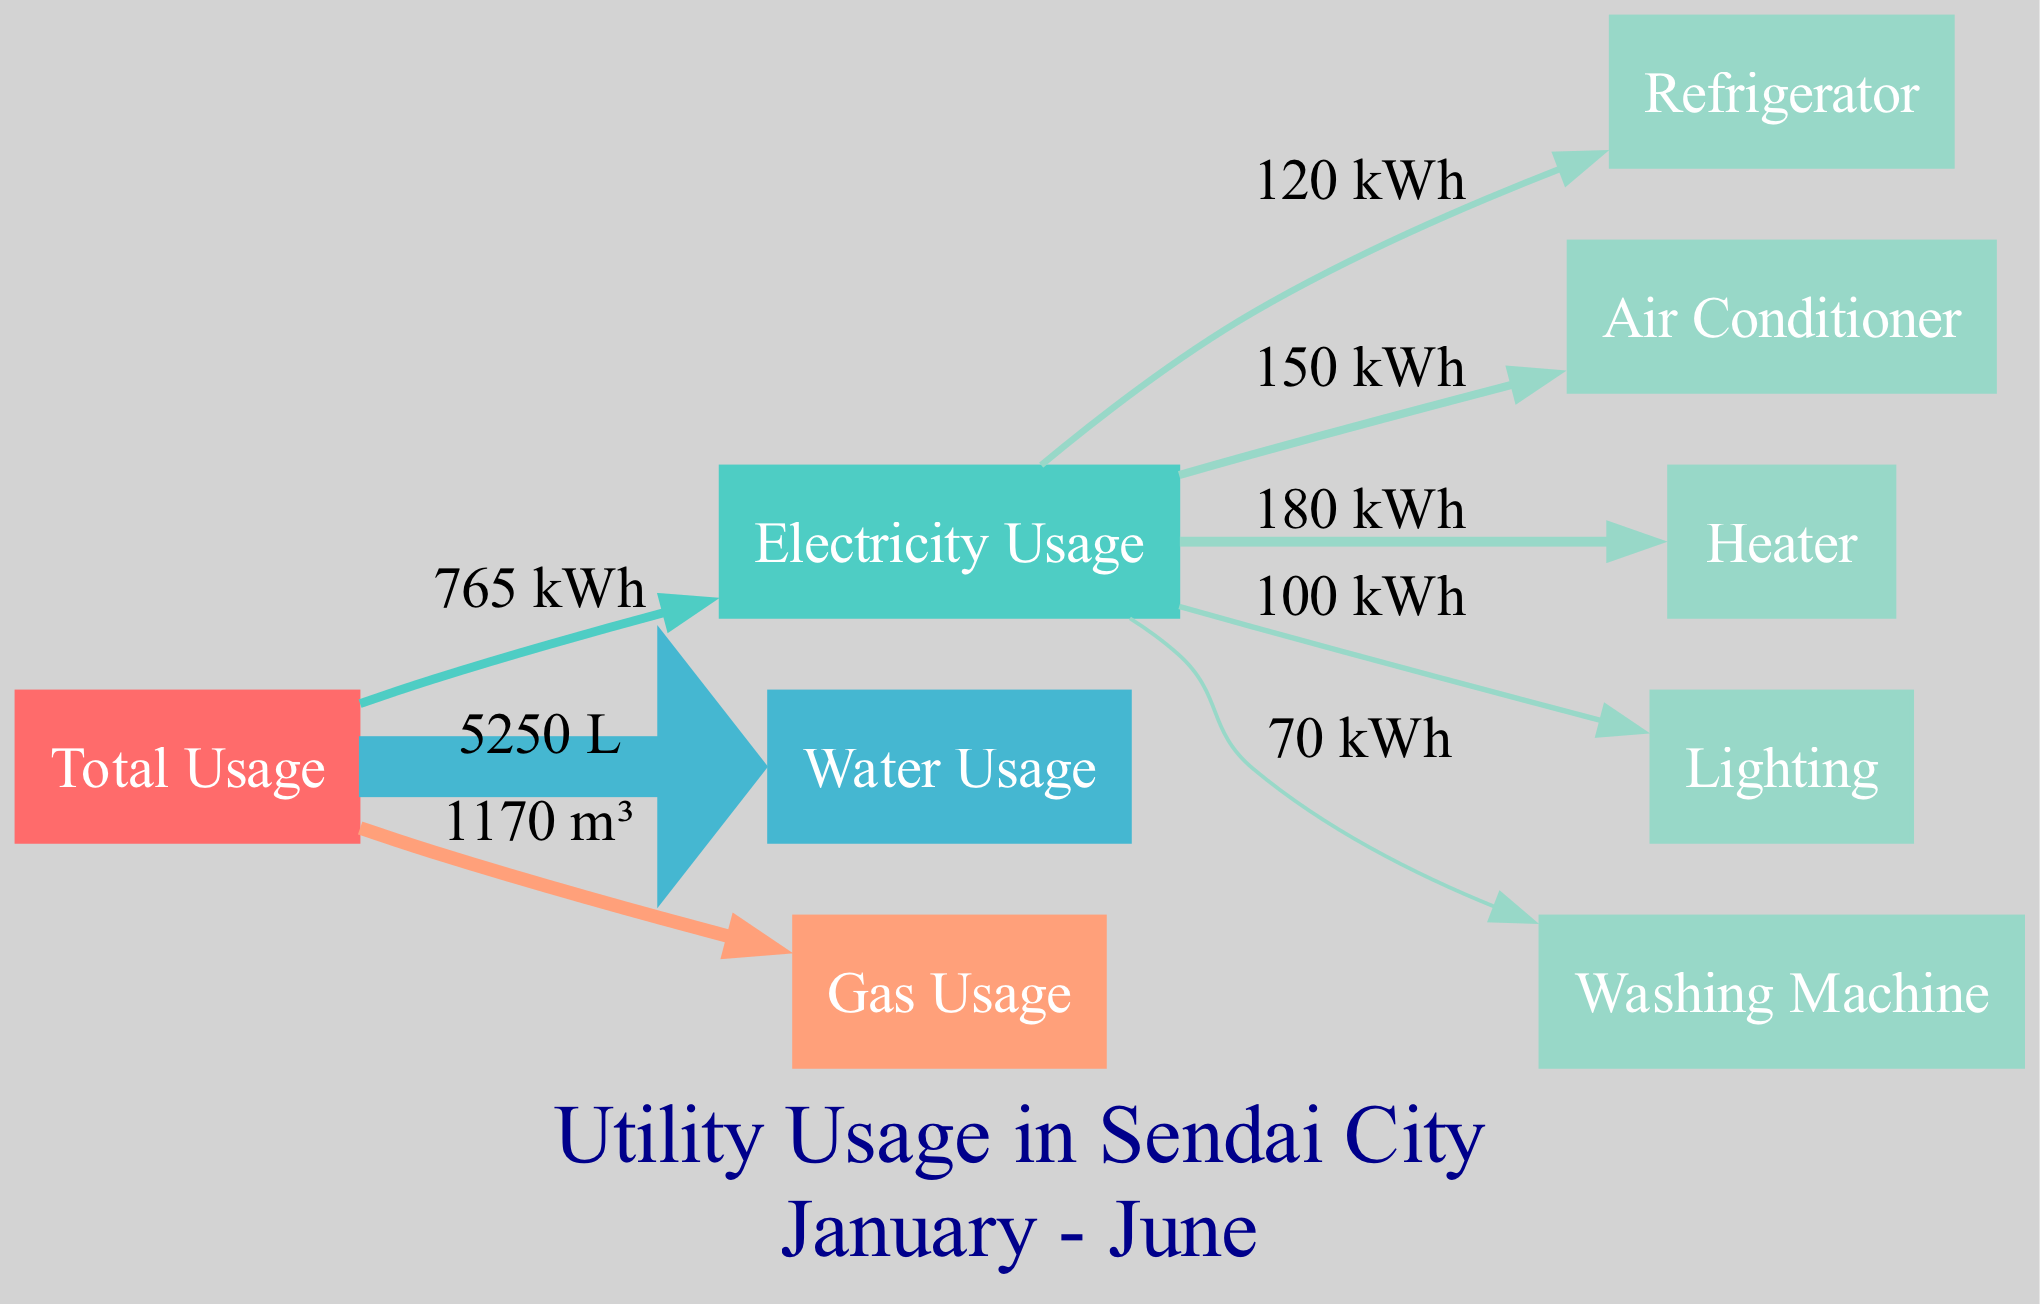What is the total electricity usage over six months? To find the total electricity usage, sum the monthly electricity usage values: 120 + 115 + 130 + 125 + 140 + 135 = 765.
Answer: 765 kWh What is the water usage in April? The diagram indicates that the water usage for April is shown as a specific value, which is listed in the water usage section: 950.
Answer: 950 L Which utility has the highest total usage? To determine which utility has the highest total usage, calculate the total for electricity (765), water (5,350), and gas (1,180). Water has the highest total usage.
Answer: Water How much gas was used in March? The gas usage for March is specifically labeled in the diagram, showing a direct value of 210.
Answer: 210 m³ Which energy appliance uses the least electricity? Evaluate the appliance usage values: Refrigerator (120), Air Conditioner (150), Heater (180), Lighting (100), and Washing Machine (70). The washing machine uses the least electricity.
Answer: Washing Machine What percentage of total usage is represented by electricity? First, calculate total usage from the total usage values: January (1220), February (1185), March (1140), April (1255), May (1210), June (1175) gives a total of 7,185. Electricity usage is 765. To find the percentage: (765/7185) * 100 gives approximately 10.65%.
Answer: Approximately 10.65% What is the flow direction of water usage in the diagram? The diagram indicates the direction of flow using edges from the total usage node to the water usage node, showing that water is a subset of total usage. The flow direction is from Total Usage to Water Usage.
Answer: Total to Water How many energy appliances are listed in the diagram? The diagram lists the energy appliances: Refrigerator, Air Conditioner, Heater, Lighting, and Washing Machine. Count these listed appliances: there are five.
Answer: Five What is the label on the edge connecting total usage to gas usage? The edge connecting total usage to gas usage displays the total gas usage amount as a label based on the summation previously calculated: 1,180.
Answer: 1,180 m³ 